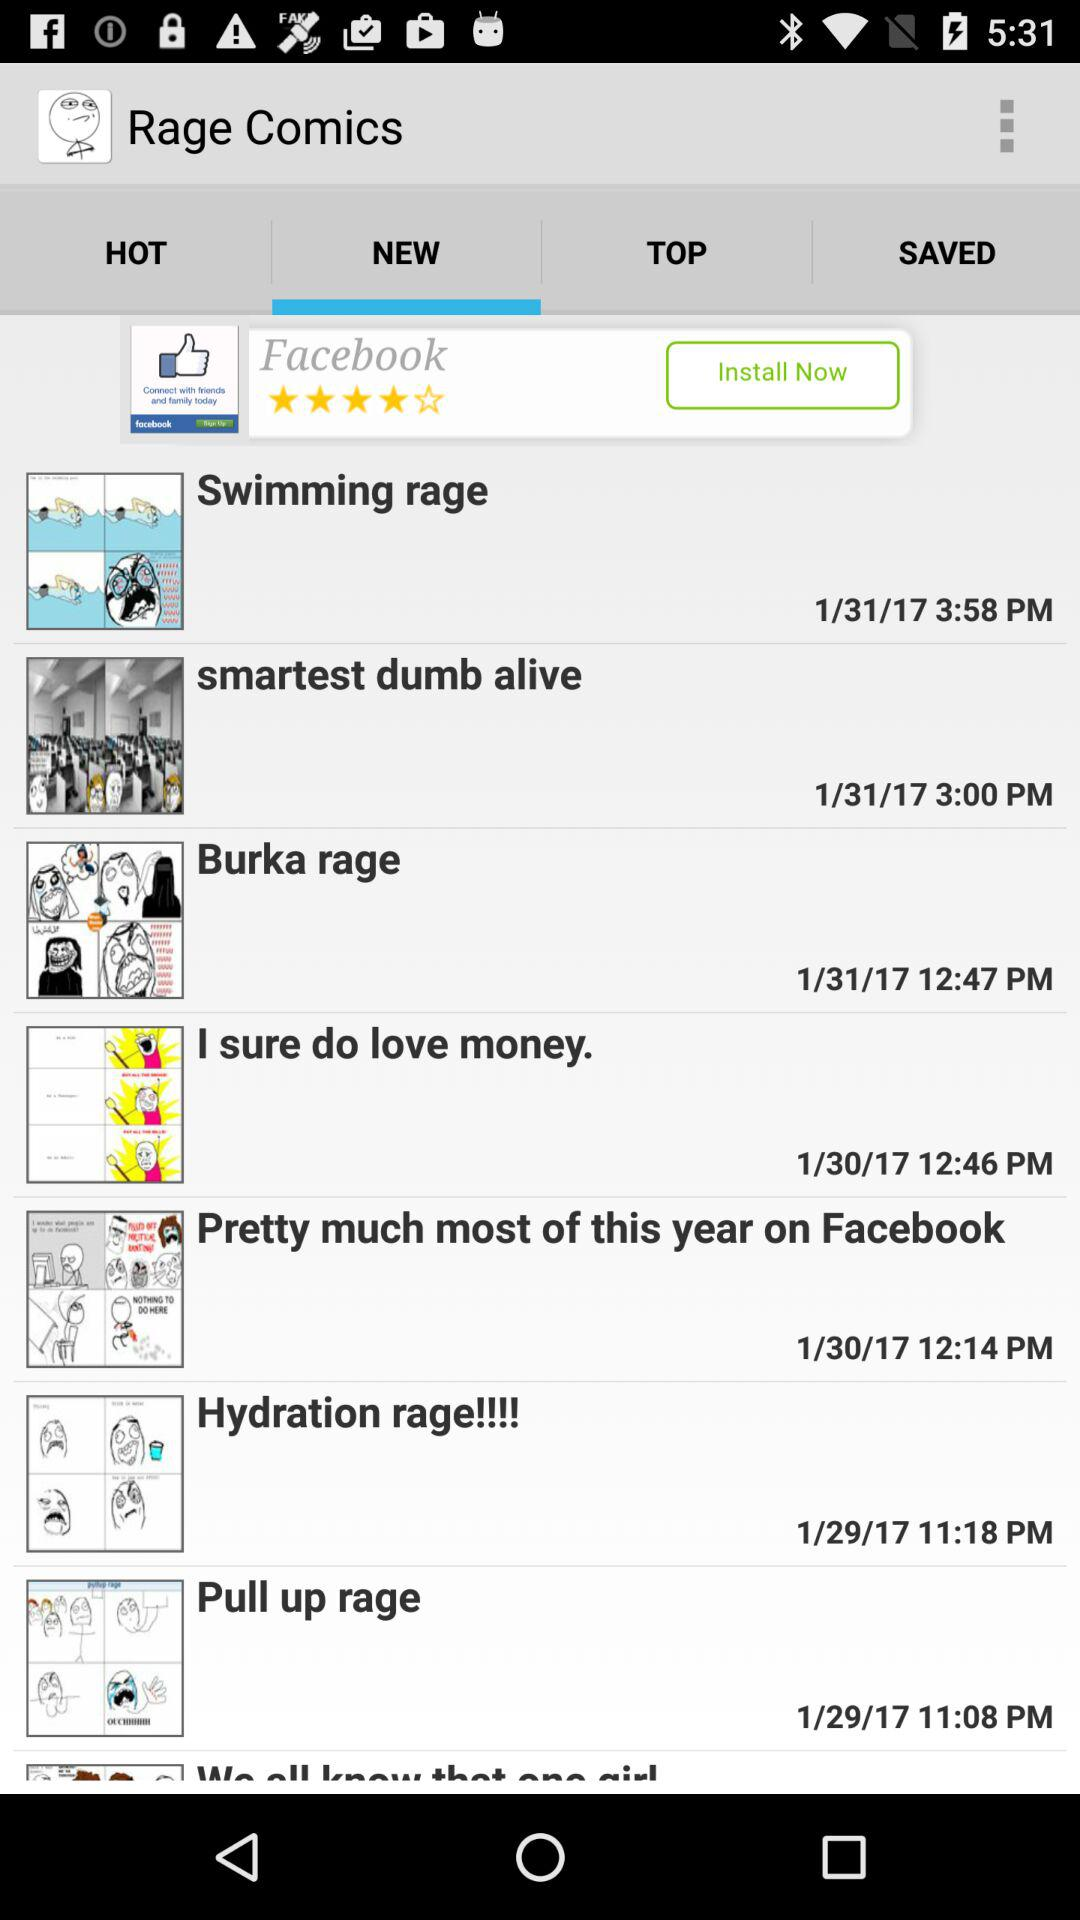Which is the selected tab for the Rage comics? The selected tab for the Rage comics is "New". 